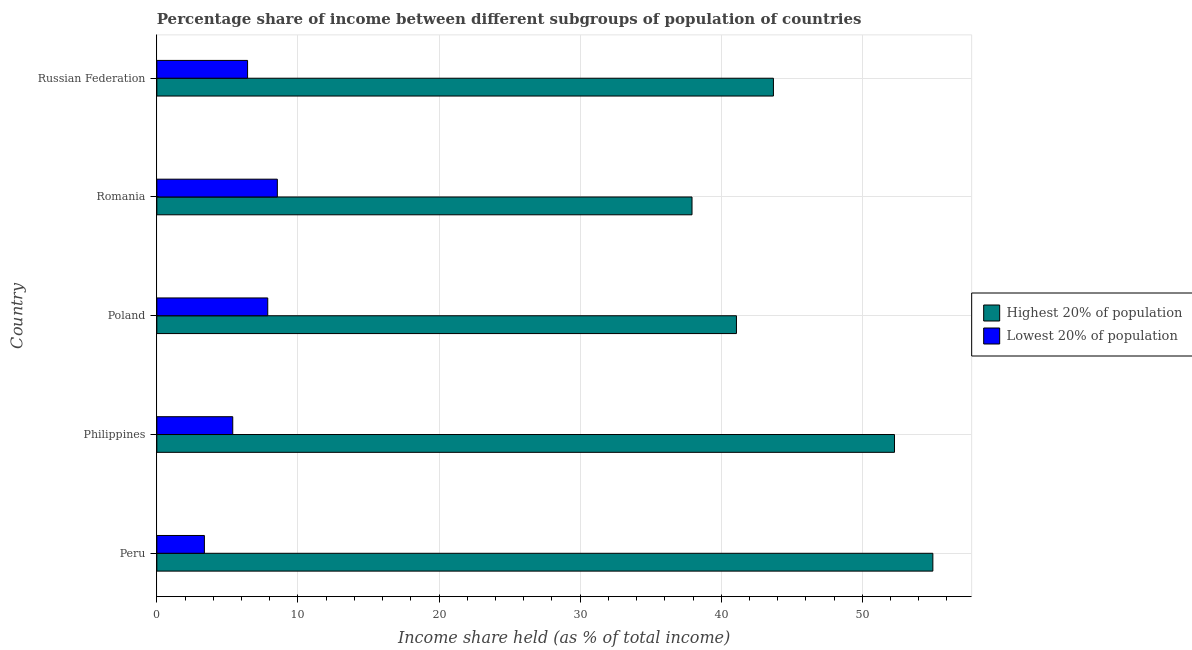How many groups of bars are there?
Ensure brevity in your answer.  5. Are the number of bars per tick equal to the number of legend labels?
Provide a short and direct response. Yes. How many bars are there on the 2nd tick from the top?
Give a very brief answer. 2. How many bars are there on the 5th tick from the bottom?
Ensure brevity in your answer.  2. What is the label of the 5th group of bars from the top?
Provide a short and direct response. Peru. In how many cases, is the number of bars for a given country not equal to the number of legend labels?
Offer a very short reply. 0. What is the income share held by lowest 20% of the population in Philippines?
Your answer should be very brief. 5.38. Across all countries, what is the minimum income share held by lowest 20% of the population?
Provide a short and direct response. 3.37. In which country was the income share held by lowest 20% of the population maximum?
Offer a very short reply. Romania. What is the total income share held by lowest 20% of the population in the graph?
Keep it short and to the point. 31.58. What is the difference between the income share held by highest 20% of the population in Philippines and that in Romania?
Your response must be concise. 14.35. What is the difference between the income share held by lowest 20% of the population in Philippines and the income share held by highest 20% of the population in Romania?
Offer a terse response. -32.55. What is the average income share held by highest 20% of the population per country?
Offer a very short reply. 46. What is the difference between the income share held by lowest 20% of the population and income share held by highest 20% of the population in Philippines?
Keep it short and to the point. -46.9. What is the ratio of the income share held by lowest 20% of the population in Peru to that in Poland?
Your response must be concise. 0.43. Is the income share held by highest 20% of the population in Peru less than that in Russian Federation?
Your answer should be compact. No. Is the difference between the income share held by lowest 20% of the population in Philippines and Romania greater than the difference between the income share held by highest 20% of the population in Philippines and Romania?
Make the answer very short. No. What is the difference between the highest and the second highest income share held by highest 20% of the population?
Provide a succinct answer. 2.72. What is the difference between the highest and the lowest income share held by highest 20% of the population?
Ensure brevity in your answer.  17.07. In how many countries, is the income share held by lowest 20% of the population greater than the average income share held by lowest 20% of the population taken over all countries?
Ensure brevity in your answer.  3. What does the 1st bar from the top in Russian Federation represents?
Ensure brevity in your answer.  Lowest 20% of population. What does the 2nd bar from the bottom in Peru represents?
Ensure brevity in your answer.  Lowest 20% of population. How many bars are there?
Ensure brevity in your answer.  10. What is the difference between two consecutive major ticks on the X-axis?
Keep it short and to the point. 10. Are the values on the major ticks of X-axis written in scientific E-notation?
Provide a short and direct response. No. How are the legend labels stacked?
Your answer should be compact. Vertical. What is the title of the graph?
Your answer should be very brief. Percentage share of income between different subgroups of population of countries. Does "Private creditors" appear as one of the legend labels in the graph?
Provide a short and direct response. No. What is the label or title of the X-axis?
Your response must be concise. Income share held (as % of total income). What is the Income share held (as % of total income) in Highest 20% of population in Peru?
Ensure brevity in your answer.  55. What is the Income share held (as % of total income) in Lowest 20% of population in Peru?
Ensure brevity in your answer.  3.37. What is the Income share held (as % of total income) in Highest 20% of population in Philippines?
Provide a succinct answer. 52.28. What is the Income share held (as % of total income) in Lowest 20% of population in Philippines?
Your answer should be compact. 5.38. What is the Income share held (as % of total income) in Highest 20% of population in Poland?
Make the answer very short. 41.08. What is the Income share held (as % of total income) of Lowest 20% of population in Poland?
Give a very brief answer. 7.86. What is the Income share held (as % of total income) of Highest 20% of population in Romania?
Provide a succinct answer. 37.93. What is the Income share held (as % of total income) in Lowest 20% of population in Romania?
Give a very brief answer. 8.54. What is the Income share held (as % of total income) of Highest 20% of population in Russian Federation?
Provide a short and direct response. 43.7. What is the Income share held (as % of total income) of Lowest 20% of population in Russian Federation?
Keep it short and to the point. 6.43. Across all countries, what is the maximum Income share held (as % of total income) in Lowest 20% of population?
Make the answer very short. 8.54. Across all countries, what is the minimum Income share held (as % of total income) of Highest 20% of population?
Provide a succinct answer. 37.93. Across all countries, what is the minimum Income share held (as % of total income) in Lowest 20% of population?
Ensure brevity in your answer.  3.37. What is the total Income share held (as % of total income) in Highest 20% of population in the graph?
Provide a short and direct response. 229.99. What is the total Income share held (as % of total income) in Lowest 20% of population in the graph?
Provide a succinct answer. 31.58. What is the difference between the Income share held (as % of total income) in Highest 20% of population in Peru and that in Philippines?
Provide a short and direct response. 2.72. What is the difference between the Income share held (as % of total income) of Lowest 20% of population in Peru and that in Philippines?
Offer a very short reply. -2.01. What is the difference between the Income share held (as % of total income) in Highest 20% of population in Peru and that in Poland?
Your answer should be very brief. 13.92. What is the difference between the Income share held (as % of total income) in Lowest 20% of population in Peru and that in Poland?
Provide a succinct answer. -4.49. What is the difference between the Income share held (as % of total income) of Highest 20% of population in Peru and that in Romania?
Give a very brief answer. 17.07. What is the difference between the Income share held (as % of total income) of Lowest 20% of population in Peru and that in Romania?
Your response must be concise. -5.17. What is the difference between the Income share held (as % of total income) of Lowest 20% of population in Peru and that in Russian Federation?
Keep it short and to the point. -3.06. What is the difference between the Income share held (as % of total income) of Highest 20% of population in Philippines and that in Poland?
Your answer should be compact. 11.2. What is the difference between the Income share held (as % of total income) in Lowest 20% of population in Philippines and that in Poland?
Your answer should be compact. -2.48. What is the difference between the Income share held (as % of total income) in Highest 20% of population in Philippines and that in Romania?
Your answer should be very brief. 14.35. What is the difference between the Income share held (as % of total income) in Lowest 20% of population in Philippines and that in Romania?
Your answer should be compact. -3.16. What is the difference between the Income share held (as % of total income) of Highest 20% of population in Philippines and that in Russian Federation?
Keep it short and to the point. 8.58. What is the difference between the Income share held (as % of total income) in Lowest 20% of population in Philippines and that in Russian Federation?
Make the answer very short. -1.05. What is the difference between the Income share held (as % of total income) in Highest 20% of population in Poland and that in Romania?
Keep it short and to the point. 3.15. What is the difference between the Income share held (as % of total income) of Lowest 20% of population in Poland and that in Romania?
Offer a terse response. -0.68. What is the difference between the Income share held (as % of total income) in Highest 20% of population in Poland and that in Russian Federation?
Offer a very short reply. -2.62. What is the difference between the Income share held (as % of total income) in Lowest 20% of population in Poland and that in Russian Federation?
Your answer should be compact. 1.43. What is the difference between the Income share held (as % of total income) in Highest 20% of population in Romania and that in Russian Federation?
Give a very brief answer. -5.77. What is the difference between the Income share held (as % of total income) of Lowest 20% of population in Romania and that in Russian Federation?
Make the answer very short. 2.11. What is the difference between the Income share held (as % of total income) in Highest 20% of population in Peru and the Income share held (as % of total income) in Lowest 20% of population in Philippines?
Provide a succinct answer. 49.62. What is the difference between the Income share held (as % of total income) in Highest 20% of population in Peru and the Income share held (as % of total income) in Lowest 20% of population in Poland?
Your response must be concise. 47.14. What is the difference between the Income share held (as % of total income) in Highest 20% of population in Peru and the Income share held (as % of total income) in Lowest 20% of population in Romania?
Offer a very short reply. 46.46. What is the difference between the Income share held (as % of total income) in Highest 20% of population in Peru and the Income share held (as % of total income) in Lowest 20% of population in Russian Federation?
Provide a short and direct response. 48.57. What is the difference between the Income share held (as % of total income) in Highest 20% of population in Philippines and the Income share held (as % of total income) in Lowest 20% of population in Poland?
Your answer should be compact. 44.42. What is the difference between the Income share held (as % of total income) of Highest 20% of population in Philippines and the Income share held (as % of total income) of Lowest 20% of population in Romania?
Provide a succinct answer. 43.74. What is the difference between the Income share held (as % of total income) of Highest 20% of population in Philippines and the Income share held (as % of total income) of Lowest 20% of population in Russian Federation?
Your answer should be compact. 45.85. What is the difference between the Income share held (as % of total income) of Highest 20% of population in Poland and the Income share held (as % of total income) of Lowest 20% of population in Romania?
Provide a succinct answer. 32.54. What is the difference between the Income share held (as % of total income) of Highest 20% of population in Poland and the Income share held (as % of total income) of Lowest 20% of population in Russian Federation?
Your answer should be very brief. 34.65. What is the difference between the Income share held (as % of total income) in Highest 20% of population in Romania and the Income share held (as % of total income) in Lowest 20% of population in Russian Federation?
Your answer should be very brief. 31.5. What is the average Income share held (as % of total income) in Highest 20% of population per country?
Your response must be concise. 46. What is the average Income share held (as % of total income) in Lowest 20% of population per country?
Offer a very short reply. 6.32. What is the difference between the Income share held (as % of total income) in Highest 20% of population and Income share held (as % of total income) in Lowest 20% of population in Peru?
Your answer should be compact. 51.63. What is the difference between the Income share held (as % of total income) in Highest 20% of population and Income share held (as % of total income) in Lowest 20% of population in Philippines?
Your answer should be very brief. 46.9. What is the difference between the Income share held (as % of total income) of Highest 20% of population and Income share held (as % of total income) of Lowest 20% of population in Poland?
Your answer should be compact. 33.22. What is the difference between the Income share held (as % of total income) in Highest 20% of population and Income share held (as % of total income) in Lowest 20% of population in Romania?
Offer a very short reply. 29.39. What is the difference between the Income share held (as % of total income) of Highest 20% of population and Income share held (as % of total income) of Lowest 20% of population in Russian Federation?
Your answer should be compact. 37.27. What is the ratio of the Income share held (as % of total income) of Highest 20% of population in Peru to that in Philippines?
Your response must be concise. 1.05. What is the ratio of the Income share held (as % of total income) in Lowest 20% of population in Peru to that in Philippines?
Give a very brief answer. 0.63. What is the ratio of the Income share held (as % of total income) of Highest 20% of population in Peru to that in Poland?
Provide a short and direct response. 1.34. What is the ratio of the Income share held (as % of total income) of Lowest 20% of population in Peru to that in Poland?
Your answer should be very brief. 0.43. What is the ratio of the Income share held (as % of total income) of Highest 20% of population in Peru to that in Romania?
Provide a succinct answer. 1.45. What is the ratio of the Income share held (as % of total income) in Lowest 20% of population in Peru to that in Romania?
Keep it short and to the point. 0.39. What is the ratio of the Income share held (as % of total income) of Highest 20% of population in Peru to that in Russian Federation?
Your answer should be very brief. 1.26. What is the ratio of the Income share held (as % of total income) in Lowest 20% of population in Peru to that in Russian Federation?
Your response must be concise. 0.52. What is the ratio of the Income share held (as % of total income) of Highest 20% of population in Philippines to that in Poland?
Provide a succinct answer. 1.27. What is the ratio of the Income share held (as % of total income) of Lowest 20% of population in Philippines to that in Poland?
Your answer should be compact. 0.68. What is the ratio of the Income share held (as % of total income) of Highest 20% of population in Philippines to that in Romania?
Your answer should be very brief. 1.38. What is the ratio of the Income share held (as % of total income) of Lowest 20% of population in Philippines to that in Romania?
Provide a short and direct response. 0.63. What is the ratio of the Income share held (as % of total income) of Highest 20% of population in Philippines to that in Russian Federation?
Your response must be concise. 1.2. What is the ratio of the Income share held (as % of total income) in Lowest 20% of population in Philippines to that in Russian Federation?
Ensure brevity in your answer.  0.84. What is the ratio of the Income share held (as % of total income) in Highest 20% of population in Poland to that in Romania?
Provide a succinct answer. 1.08. What is the ratio of the Income share held (as % of total income) of Lowest 20% of population in Poland to that in Romania?
Give a very brief answer. 0.92. What is the ratio of the Income share held (as % of total income) in Highest 20% of population in Poland to that in Russian Federation?
Offer a terse response. 0.94. What is the ratio of the Income share held (as % of total income) in Lowest 20% of population in Poland to that in Russian Federation?
Provide a short and direct response. 1.22. What is the ratio of the Income share held (as % of total income) in Highest 20% of population in Romania to that in Russian Federation?
Offer a terse response. 0.87. What is the ratio of the Income share held (as % of total income) of Lowest 20% of population in Romania to that in Russian Federation?
Offer a very short reply. 1.33. What is the difference between the highest and the second highest Income share held (as % of total income) in Highest 20% of population?
Give a very brief answer. 2.72. What is the difference between the highest and the second highest Income share held (as % of total income) in Lowest 20% of population?
Keep it short and to the point. 0.68. What is the difference between the highest and the lowest Income share held (as % of total income) in Highest 20% of population?
Make the answer very short. 17.07. What is the difference between the highest and the lowest Income share held (as % of total income) of Lowest 20% of population?
Give a very brief answer. 5.17. 